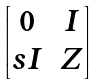<formula> <loc_0><loc_0><loc_500><loc_500>\begin{bmatrix} 0 & I \\ s I & Z \end{bmatrix}</formula> 